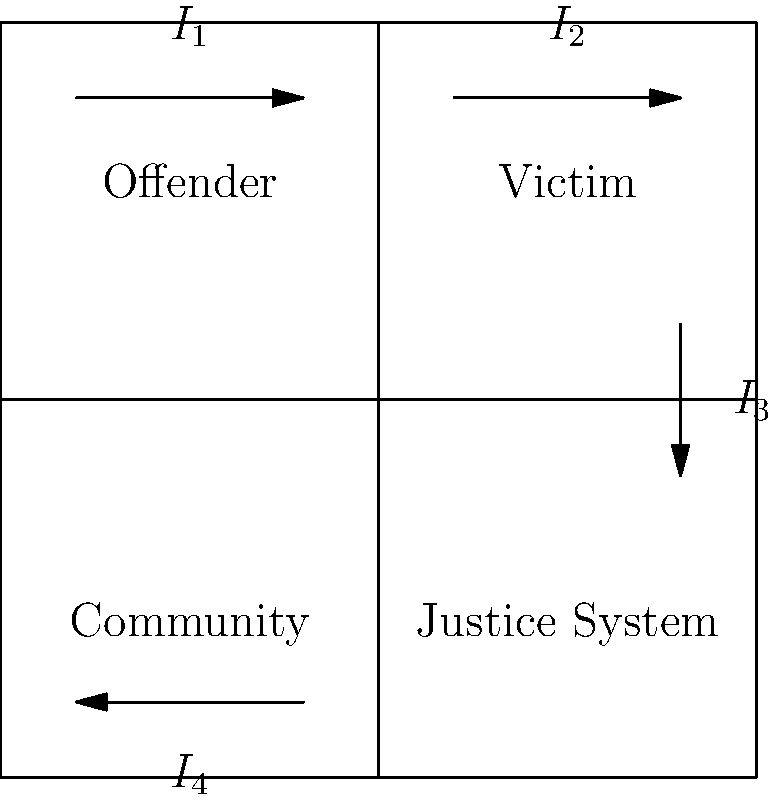In the circuit diagram representing a basic restorative justice program implementation, which current flow ($I_1$, $I_2$, $I_3$, or $I_4$) represents the direct interaction between the offender and the victim? To answer this question, we need to analyze the circuit diagram and understand what each component and current flow represents in the context of a restorative justice program:

1. The diagram is divided into four quadrants, representing key stakeholders in a restorative justice process: Offender, Victim, Community, and Justice System.

2. The arrows represent the flow of interaction or communication between these stakeholders.

3. $I_1$ flows from the Offender to the Victim quadrant.
4. $I_2$ flows within the Victim quadrant.
5. $I_3$ flows from the Victim to the Justice System quadrant.
6. $I_4$ flows from the Community to the Offender quadrant.

In a restorative justice program, the direct interaction between the offender and the victim is a crucial component. This interaction typically involves dialogue, understanding the impact of the offense, and working towards resolution or reparation.

Given this context, the current flow that represents the direct interaction between the offender and the victim is $I_1$, as it flows directly from the Offender quadrant to the Victim quadrant.
Answer: $I_1$ 